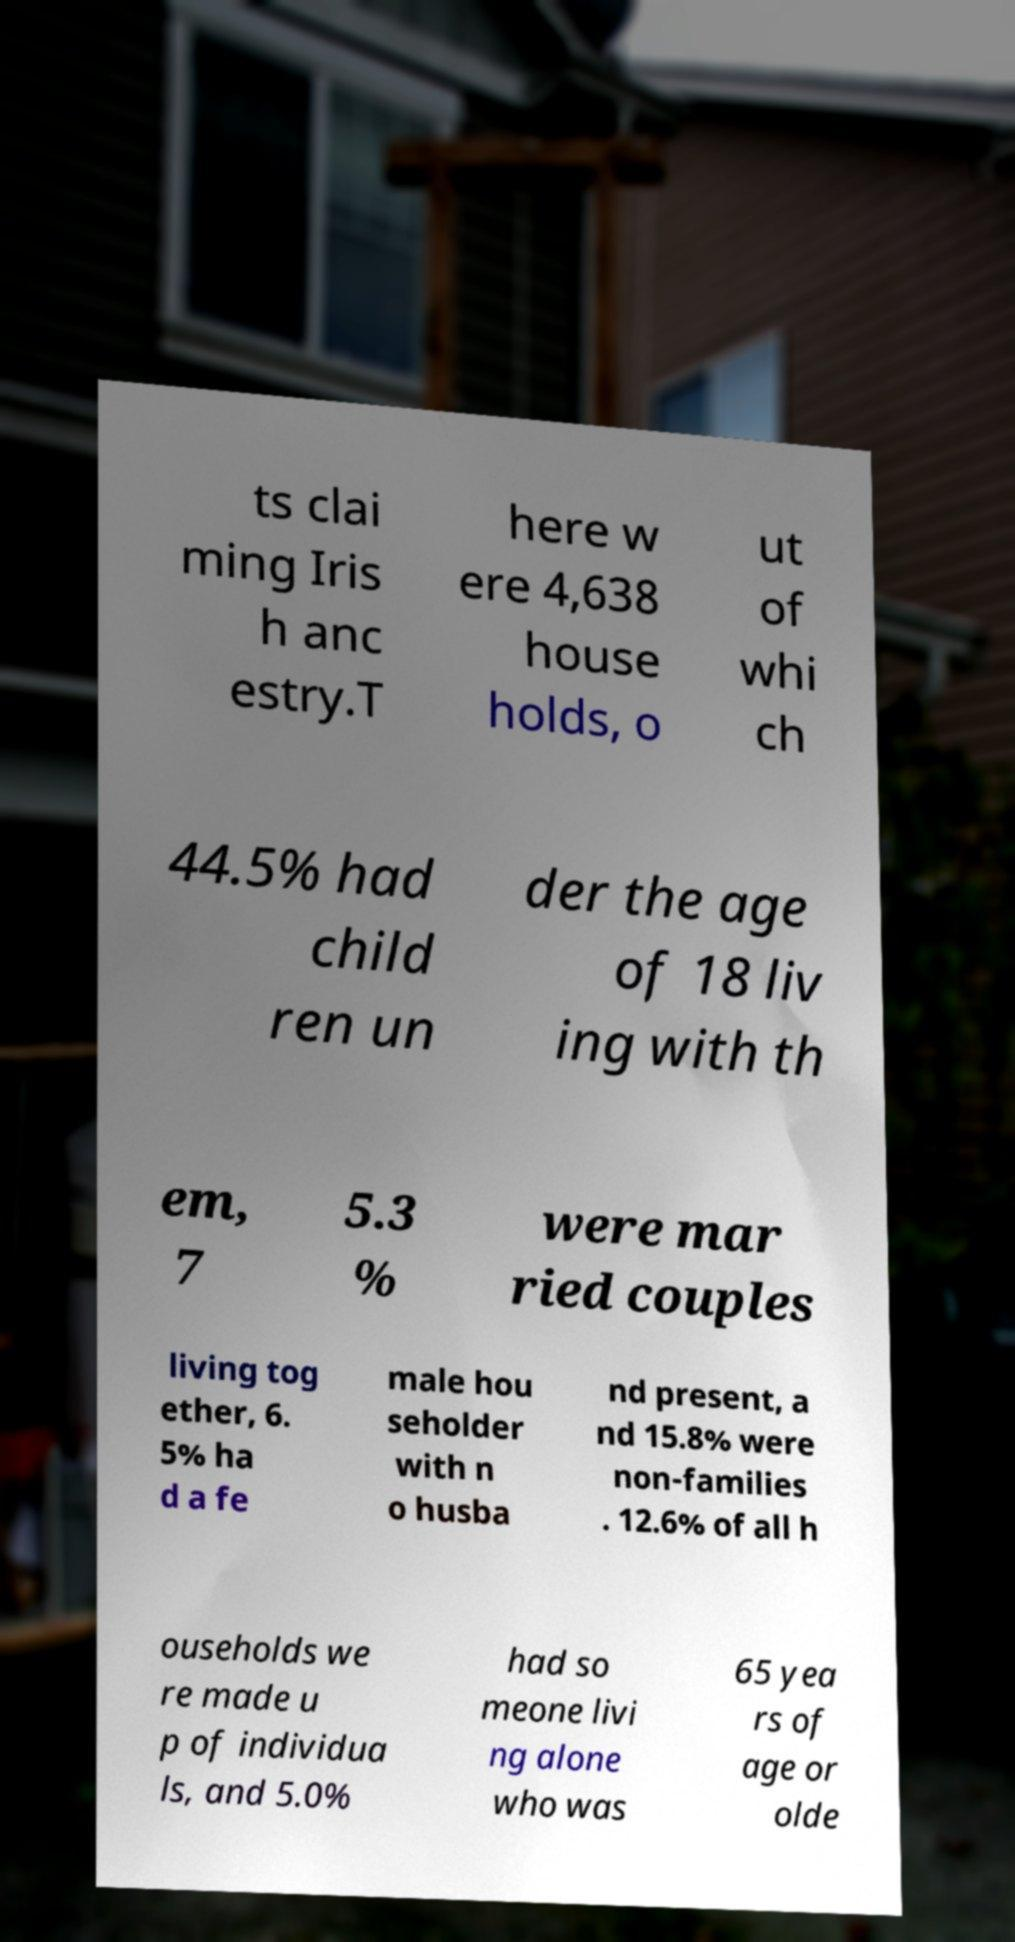Could you extract and type out the text from this image? ts clai ming Iris h anc estry.T here w ere 4,638 house holds, o ut of whi ch 44.5% had child ren un der the age of 18 liv ing with th em, 7 5.3 % were mar ried couples living tog ether, 6. 5% ha d a fe male hou seholder with n o husba nd present, a nd 15.8% were non-families . 12.6% of all h ouseholds we re made u p of individua ls, and 5.0% had so meone livi ng alone who was 65 yea rs of age or olde 